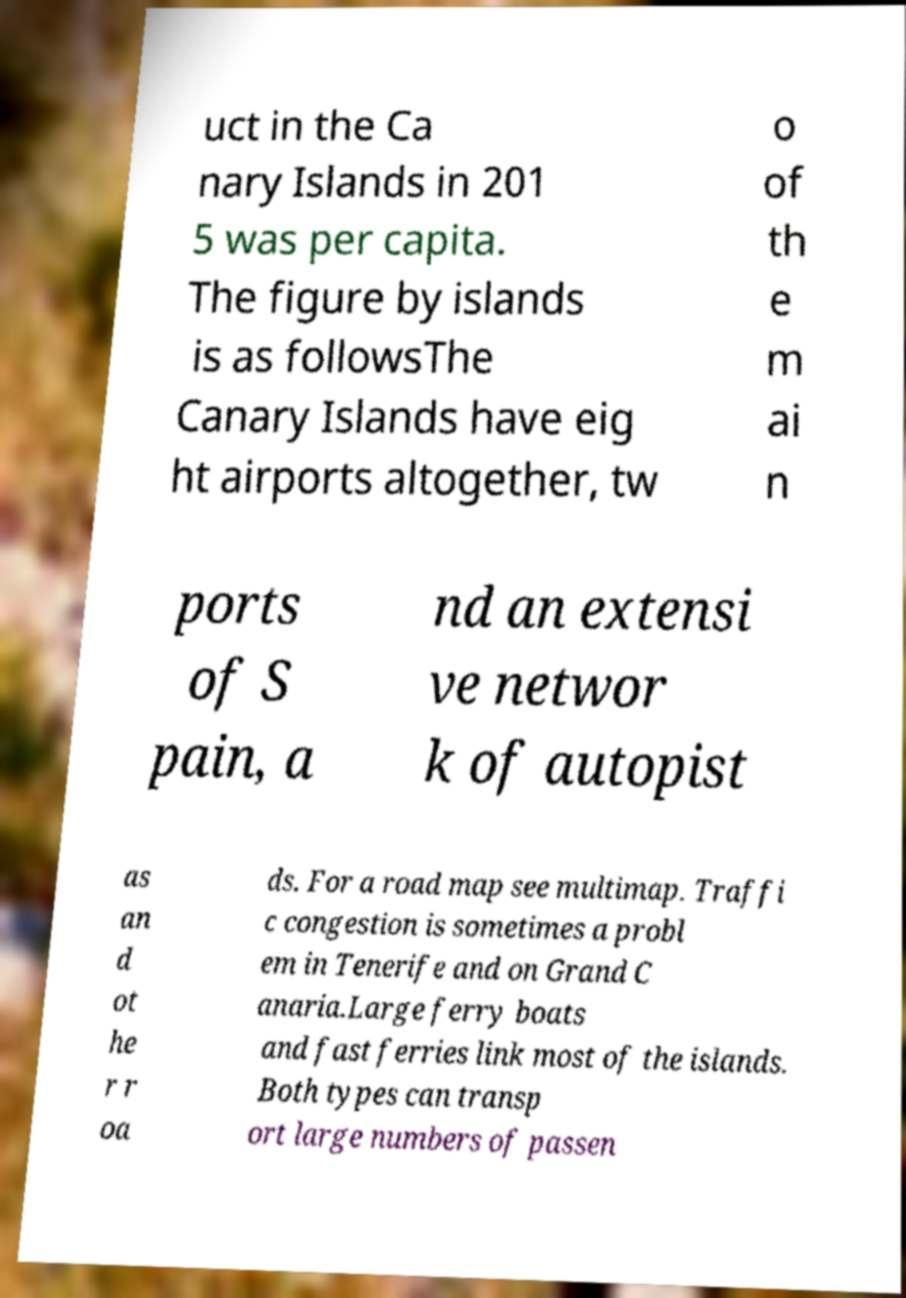Could you extract and type out the text from this image? uct in the Ca nary Islands in 201 5 was per capita. The figure by islands is as followsThe Canary Islands have eig ht airports altogether, tw o of th e m ai n ports of S pain, a nd an extensi ve networ k of autopist as an d ot he r r oa ds. For a road map see multimap. Traffi c congestion is sometimes a probl em in Tenerife and on Grand C anaria.Large ferry boats and fast ferries link most of the islands. Both types can transp ort large numbers of passen 